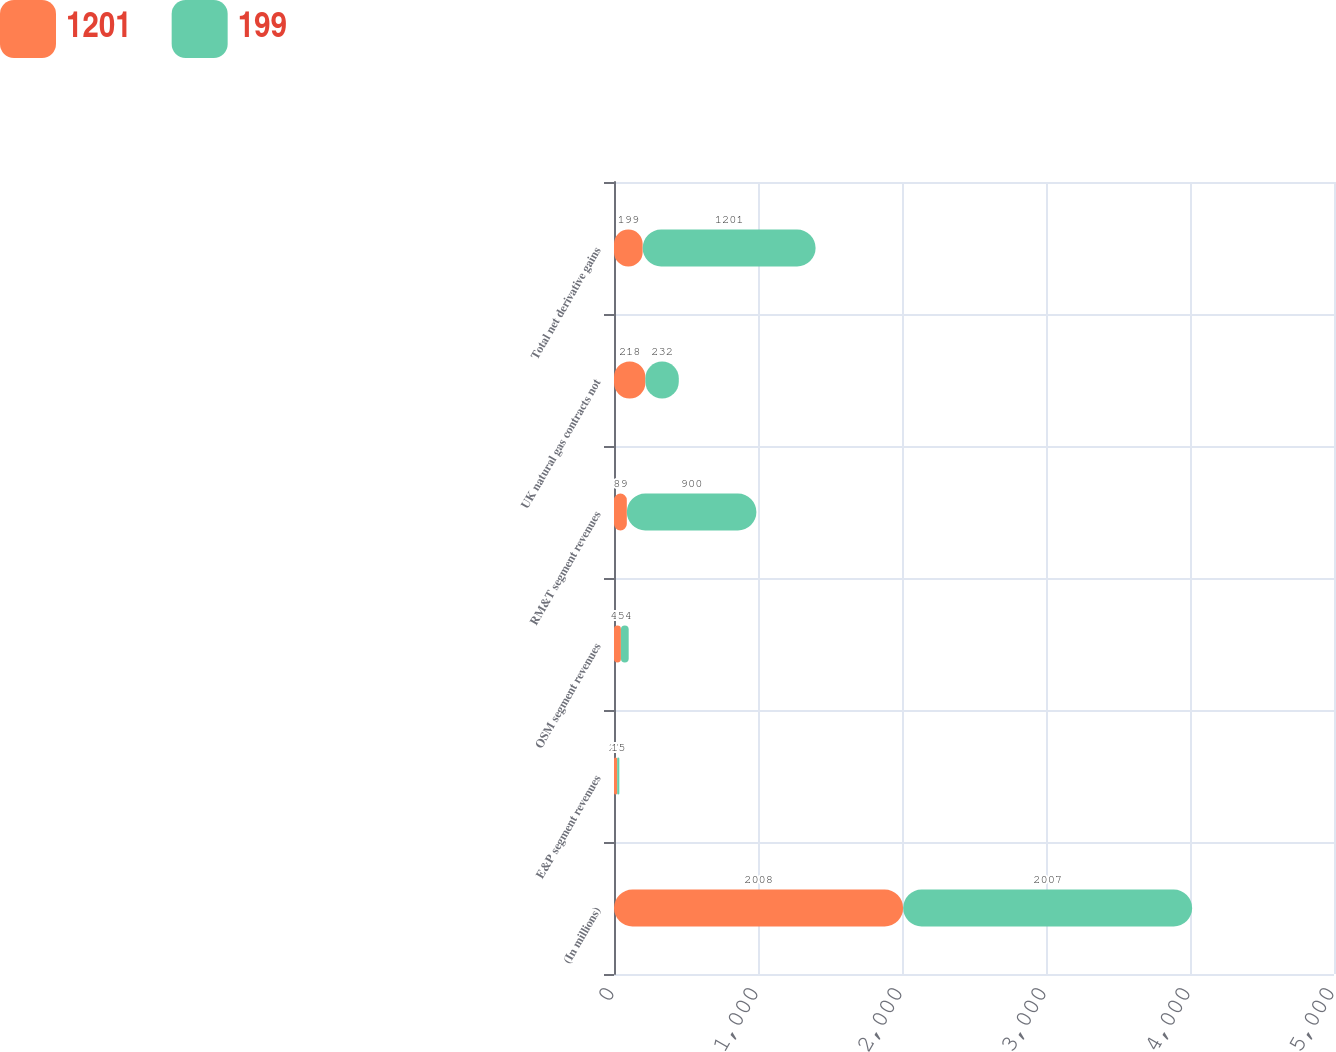<chart> <loc_0><loc_0><loc_500><loc_500><stacked_bar_chart><ecel><fcel>(In millions)<fcel>E&P segment revenues<fcel>OSM segment revenues<fcel>RM&T segment revenues<fcel>UK natural gas contracts not<fcel>Total net derivative gains<nl><fcel>1201<fcel>2008<fcel>22<fcel>48<fcel>89<fcel>218<fcel>199<nl><fcel>199<fcel>2007<fcel>15<fcel>54<fcel>900<fcel>232<fcel>1201<nl></chart> 